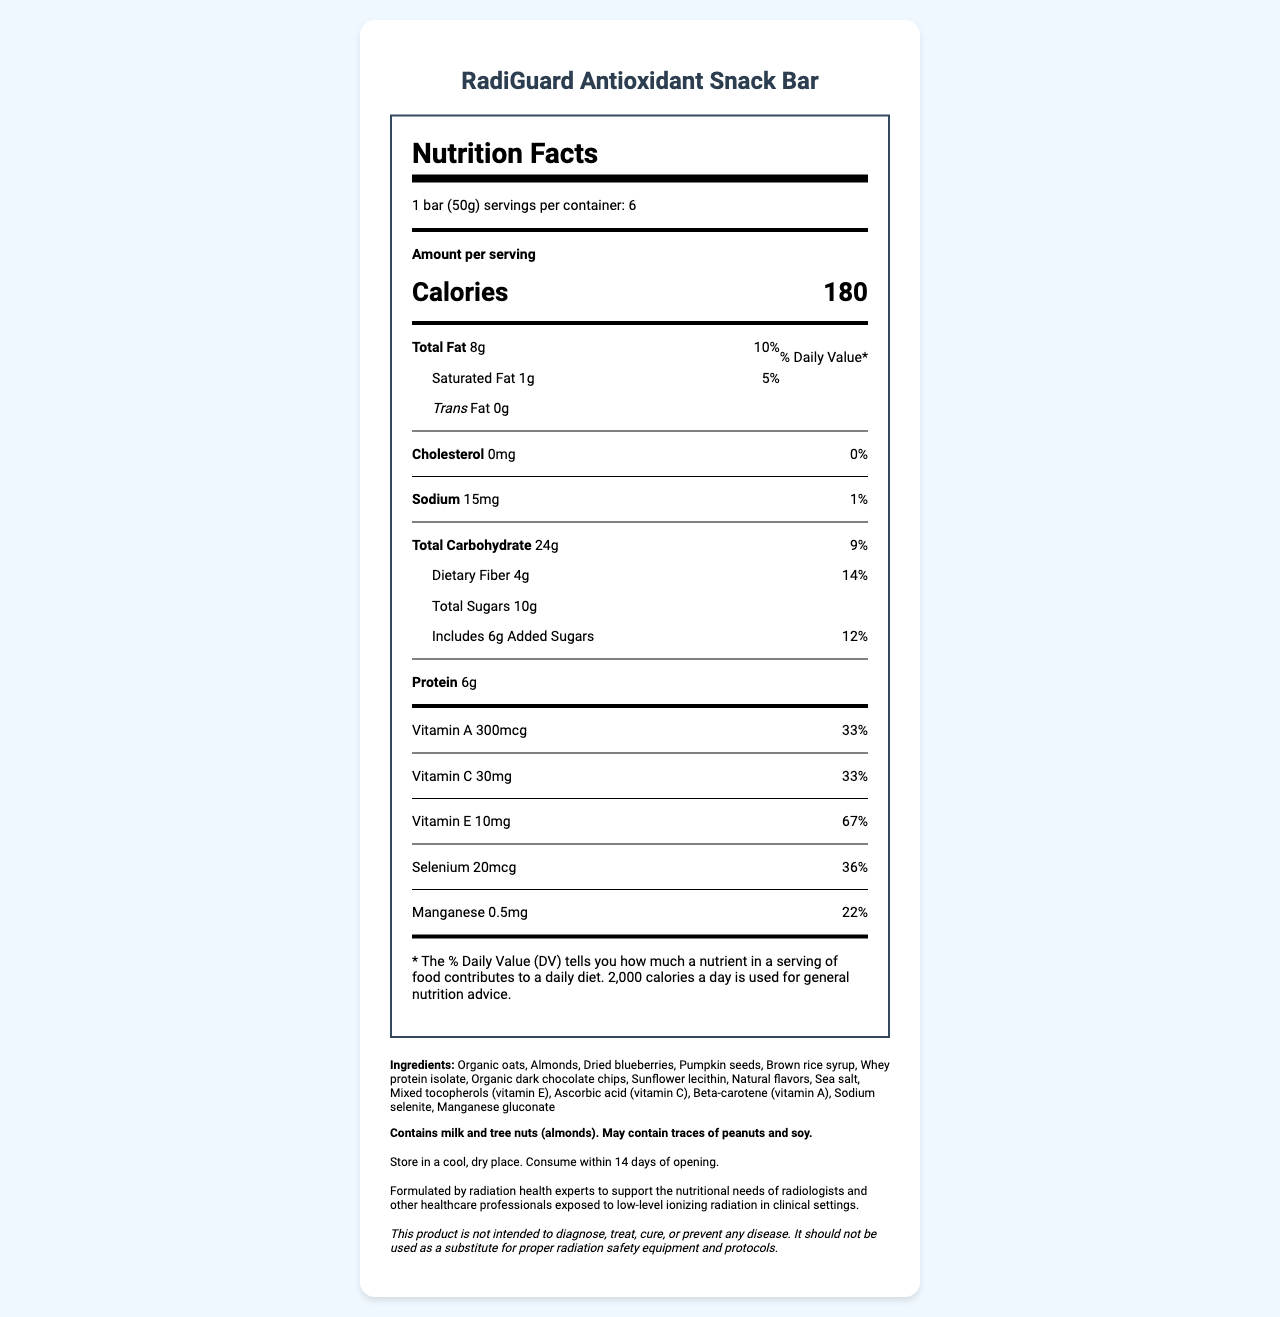How many calories are there per serving of the RadiGuard Antioxidant Snack Bar? The nutrition label specifies that there are 180 calories per serving.
Answer: 180 What is the serving size of the RadiGuard Antioxidant Snack Bar? The nutrition label indicates that the serving size is one bar, which is 50 grams.
Answer: 1 bar (50g) How many grams of dietary fiber does one serving contain? The nutrition label shows that one serving contains 4 grams of dietary fiber.
Answer: 4g What is the percentage of the daily value of Vitamin E in one serving? The nutrition label provides that one serving has 67% of the daily value for Vitamin E.
Answer: 67% What should you do with the RadiGuard Antioxidant Snack Bar after opening it? The storage instructions state that the snack bar should be consumed within 14 days of opening.
Answer: Consume within 14 days Which of the following ingredients is a potential allergen found in the RadiGuard Antioxidant Snack Bar? A. Peanuts B. Milk C. Soy D. Corn The allergen information specifies that the bar contains milk and tree nuts.
Answer: B. Milk What is the total amount of sugars in one serving, including added sugars? The nutrition label lists the total sugars as 10 grams, with 6 grams being added sugars.
Answer: 10g What percentage does the daily value of manganese in one serving of the RadiGuard Antioxidant Snack Bar account for? The nutrition label indicates that one serving accounts for 22% of the daily value of manganese.
Answer: 22% What is the recommended storage condition for the RadiGuard Antioxidant Snack Bar? The storage instructions advise to store the product in a cool, dry place.
Answer: Store in a cool, dry place Does the RadiGuard Antioxidant Snack Bar contain any cholesterol? The nutrition label states that the bar contains 0mg of cholesterol, which is 0% of the daily value.
Answer: No Summarize the nutrition and health aspects of the RadiGuard Antioxidant Snack Bar. This bar is formulated to provide antioxidant benefits and nutritional support, focusing on vitamins that combat oxidative stress, while keeping low sodium and cholesterol levels.
Answer: The RadiGuard Antioxidant Snack Bar provides a balanced nutrient profile with significant contributions of antioxidants like Vitamins A, C, and E, designed to help protect against oxidative stress from radiation exposure. It is low in sodium and cholesterol, contains 6 grams of protein, and 4 grams of dietary fiber per serving. The snack also includes added sugars and has a blend of ingredients such as organic oats, almonds, and dried blueberries. It is recommended for radiologists and healthcare professionals exposed to radiation. What is the primary purpose of the RadiGuard Antioxidant Snack Bar according to the manufacturer? The manufacturer statement mentions that the bar is specifically formulated for healthcare professionals exposed to radiation.
Answer: To support the nutritional needs of radiologists and other healthcare professionals exposed to low-level ionizing radiation Can the RadiGuard Antioxidant Snack Bar be used as a substitute for proper radiation safety equipment and protocols? The disclaimer clearly states that the bar should not be used as a substitute for proper radiation safety equipment and protocols.
Answer: No Is there any information on the environmental impact of the packaging used for the RadiGuard Antioxidant Snack Bar? The document does not provide any information regarding the environmental impact of the packaging.
Answer: Cannot be determined 